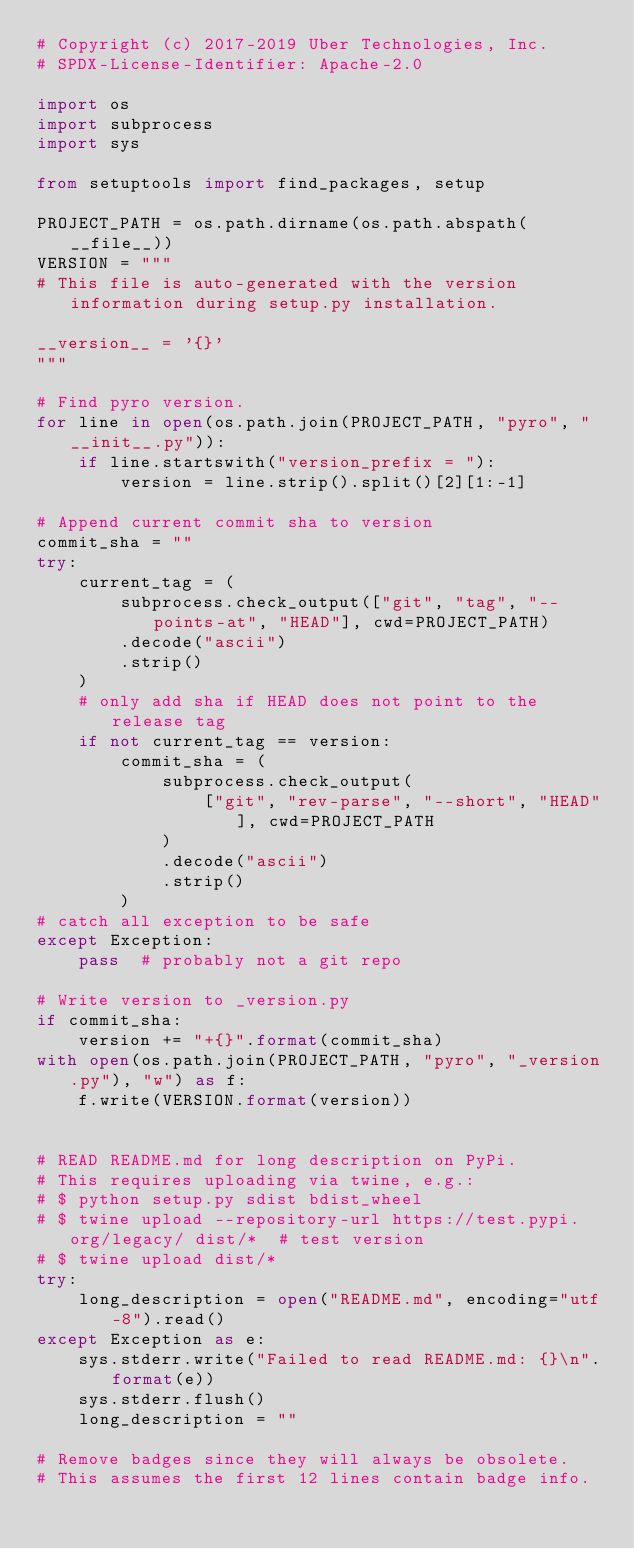<code> <loc_0><loc_0><loc_500><loc_500><_Python_># Copyright (c) 2017-2019 Uber Technologies, Inc.
# SPDX-License-Identifier: Apache-2.0

import os
import subprocess
import sys

from setuptools import find_packages, setup

PROJECT_PATH = os.path.dirname(os.path.abspath(__file__))
VERSION = """
# This file is auto-generated with the version information during setup.py installation.

__version__ = '{}'
"""

# Find pyro version.
for line in open(os.path.join(PROJECT_PATH, "pyro", "__init__.py")):
    if line.startswith("version_prefix = "):
        version = line.strip().split()[2][1:-1]

# Append current commit sha to version
commit_sha = ""
try:
    current_tag = (
        subprocess.check_output(["git", "tag", "--points-at", "HEAD"], cwd=PROJECT_PATH)
        .decode("ascii")
        .strip()
    )
    # only add sha if HEAD does not point to the release tag
    if not current_tag == version:
        commit_sha = (
            subprocess.check_output(
                ["git", "rev-parse", "--short", "HEAD"], cwd=PROJECT_PATH
            )
            .decode("ascii")
            .strip()
        )
# catch all exception to be safe
except Exception:
    pass  # probably not a git repo

# Write version to _version.py
if commit_sha:
    version += "+{}".format(commit_sha)
with open(os.path.join(PROJECT_PATH, "pyro", "_version.py"), "w") as f:
    f.write(VERSION.format(version))


# READ README.md for long description on PyPi.
# This requires uploading via twine, e.g.:
# $ python setup.py sdist bdist_wheel
# $ twine upload --repository-url https://test.pypi.org/legacy/ dist/*  # test version
# $ twine upload dist/*
try:
    long_description = open("README.md", encoding="utf-8").read()
except Exception as e:
    sys.stderr.write("Failed to read README.md: {}\n".format(e))
    sys.stderr.flush()
    long_description = ""

# Remove badges since they will always be obsolete.
# This assumes the first 12 lines contain badge info.</code> 